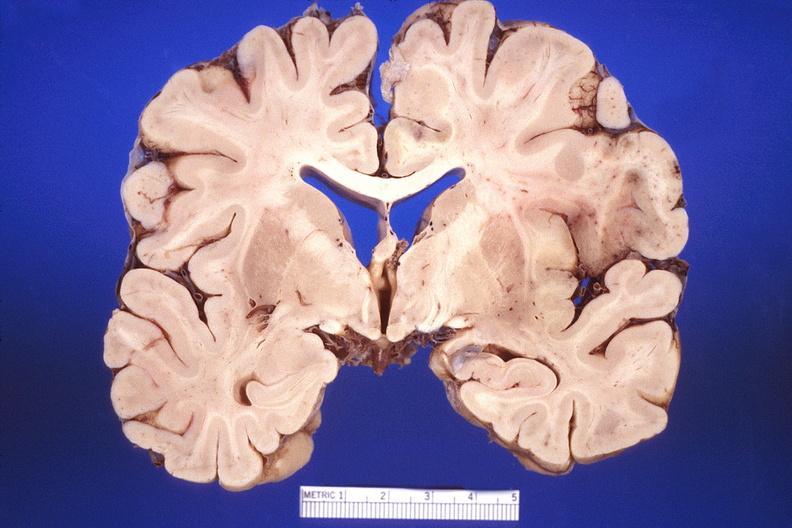does this image show brain, herpes encephalitis?
Answer the question using a single word or phrase. Yes 